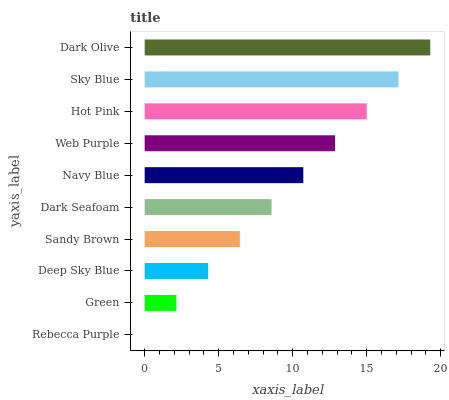Is Rebecca Purple the minimum?
Answer yes or no. Yes. Is Dark Olive the maximum?
Answer yes or no. Yes. Is Green the minimum?
Answer yes or no. No. Is Green the maximum?
Answer yes or no. No. Is Green greater than Rebecca Purple?
Answer yes or no. Yes. Is Rebecca Purple less than Green?
Answer yes or no. Yes. Is Rebecca Purple greater than Green?
Answer yes or no. No. Is Green less than Rebecca Purple?
Answer yes or no. No. Is Navy Blue the high median?
Answer yes or no. Yes. Is Dark Seafoam the low median?
Answer yes or no. Yes. Is Web Purple the high median?
Answer yes or no. No. Is Dark Olive the low median?
Answer yes or no. No. 